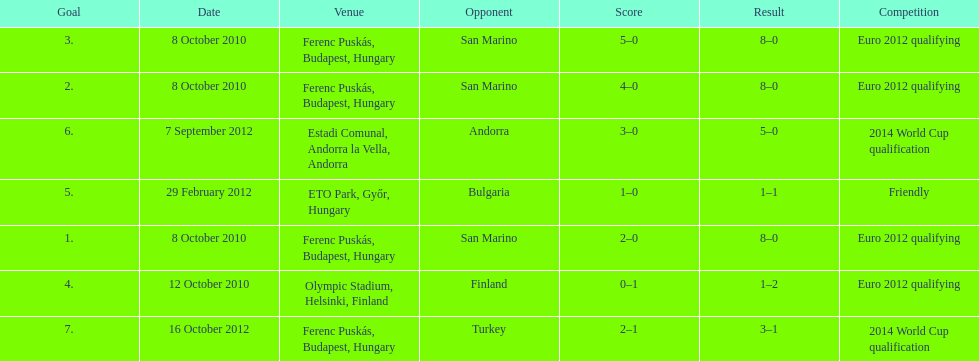How many games did he score but his team lost? 1. 